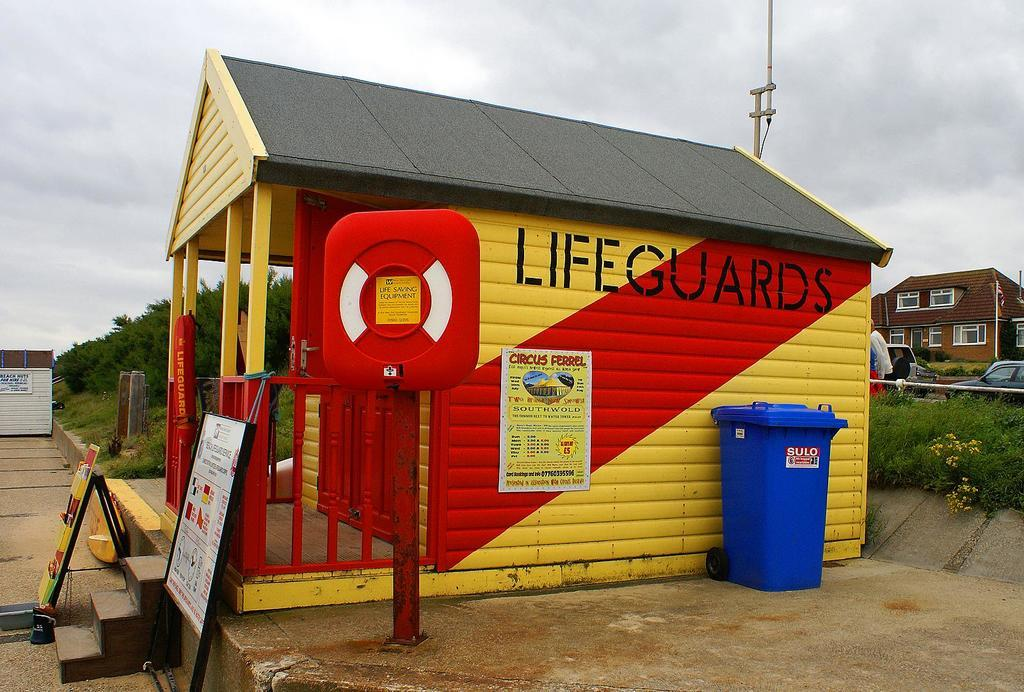<image>
Share a concise interpretation of the image provided. A red and yellow shack on a beach has "LIFEGUARDS" written on it. 